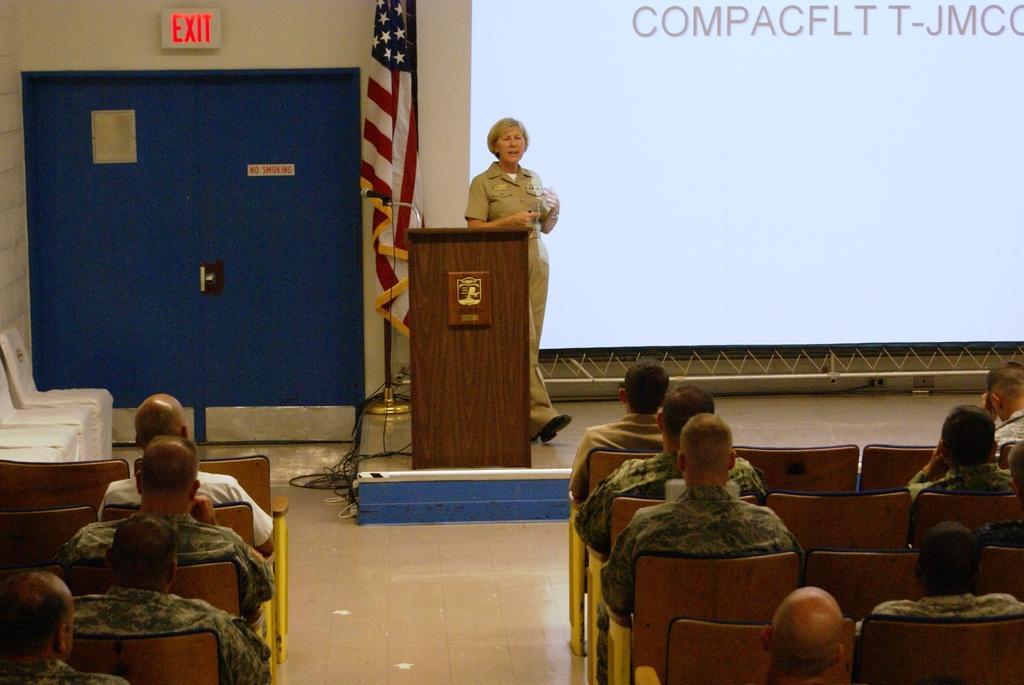Could you give a brief overview of what you see in this image? In this picture we can see a woman standing on the path. There is a podium. We can see a flag, door and an EXIT signboard on the wall. There are few chairs and some people are sitting on the chair. We can see a screen on the right side. 